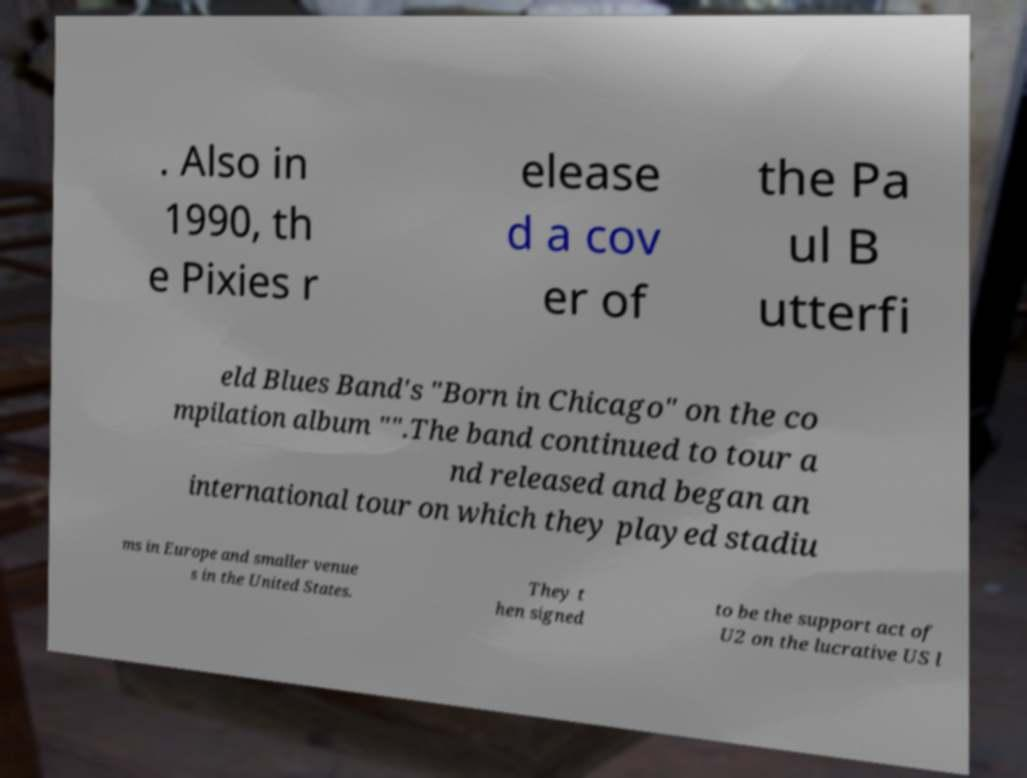Could you extract and type out the text from this image? . Also in 1990, th e Pixies r elease d a cov er of the Pa ul B utterfi eld Blues Band's "Born in Chicago" on the co mpilation album "".The band continued to tour a nd released and began an international tour on which they played stadiu ms in Europe and smaller venue s in the United States. They t hen signed to be the support act of U2 on the lucrative US l 